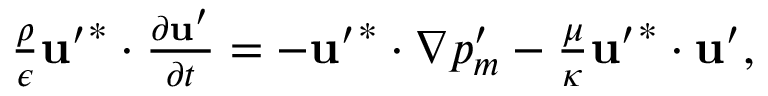<formula> <loc_0><loc_0><loc_500><loc_500>\begin{array} { r } { \frac { \rho } { \epsilon } u ^ { \prime } ^ { * } \cdot \frac { \partial u ^ { \prime } } { \partial t } = - u ^ { \prime } ^ { * } \cdot \nabla p _ { m } ^ { \prime } - \frac { \mu } { \kappa } u ^ { \prime } ^ { * } \cdot u ^ { \prime } , } \end{array}</formula> 